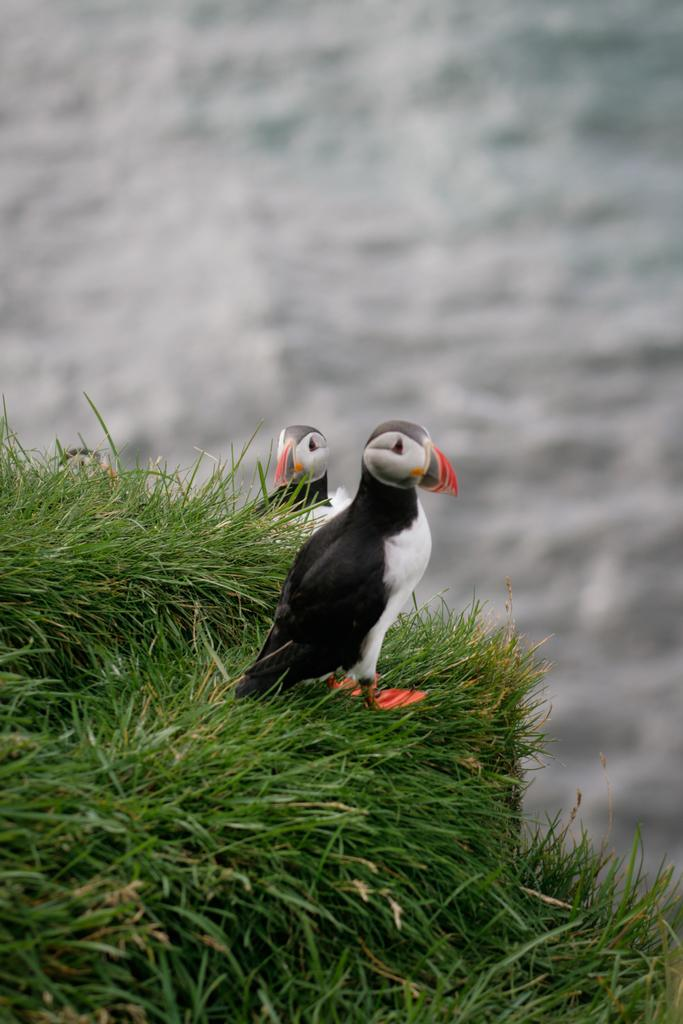How many birds are present in the image? There are two birds in the image. Where are the birds located? The birds are on the grass. Can you describe the background of the image? The background of the image is blurred. What type of grain can be seen on the sidewalk in the image? There is no sidewalk or grain present in the image; it features two birds on the grass with a blurred background. 